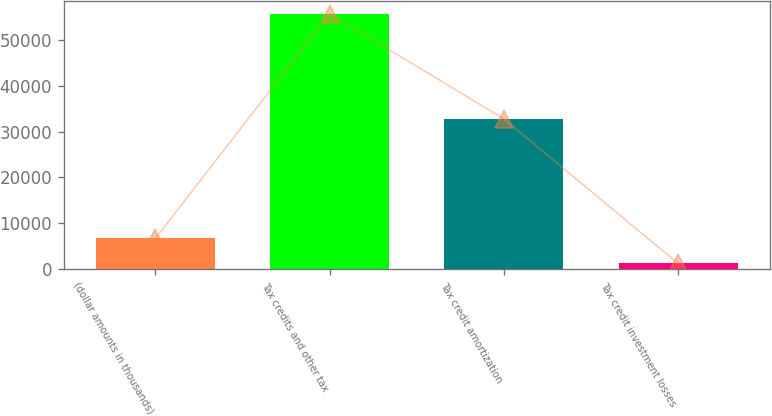Convert chart. <chart><loc_0><loc_0><loc_500><loc_500><bar_chart><fcel>(dollar amounts in thousands)<fcel>Tax credits and other tax<fcel>Tax credit amortization<fcel>Tax credit investment losses<nl><fcel>6640.3<fcel>55819<fcel>32789<fcel>1176<nl></chart> 